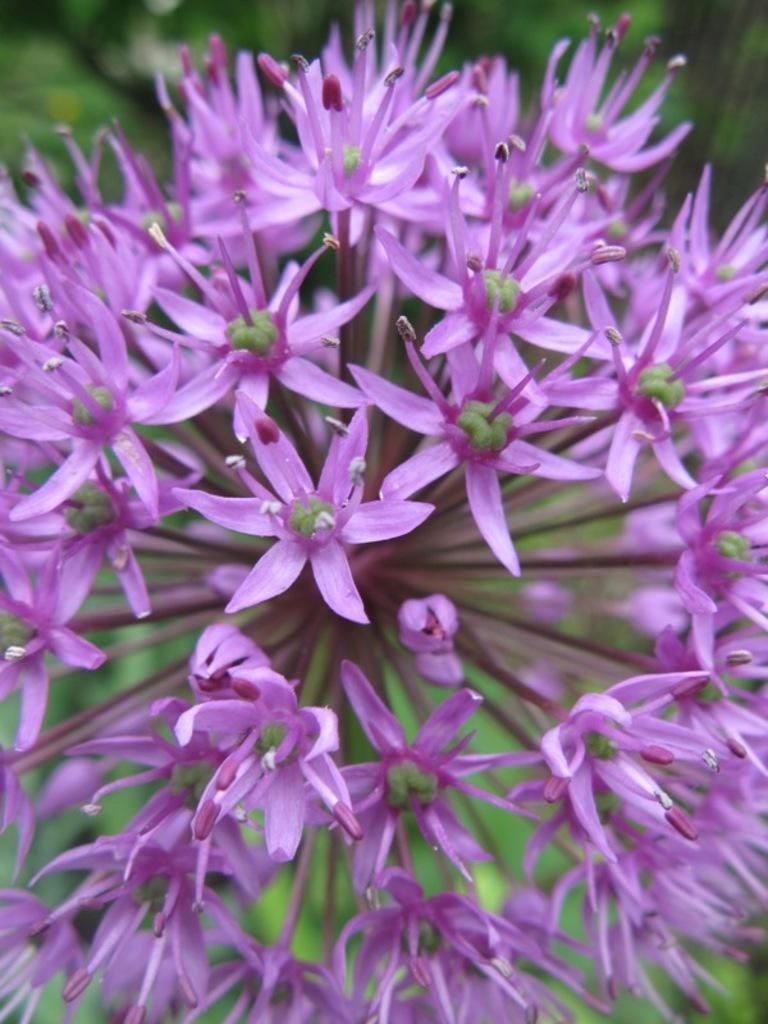In one or two sentences, can you explain what this image depicts? In this picture, there are flowers which are in purple in color. 